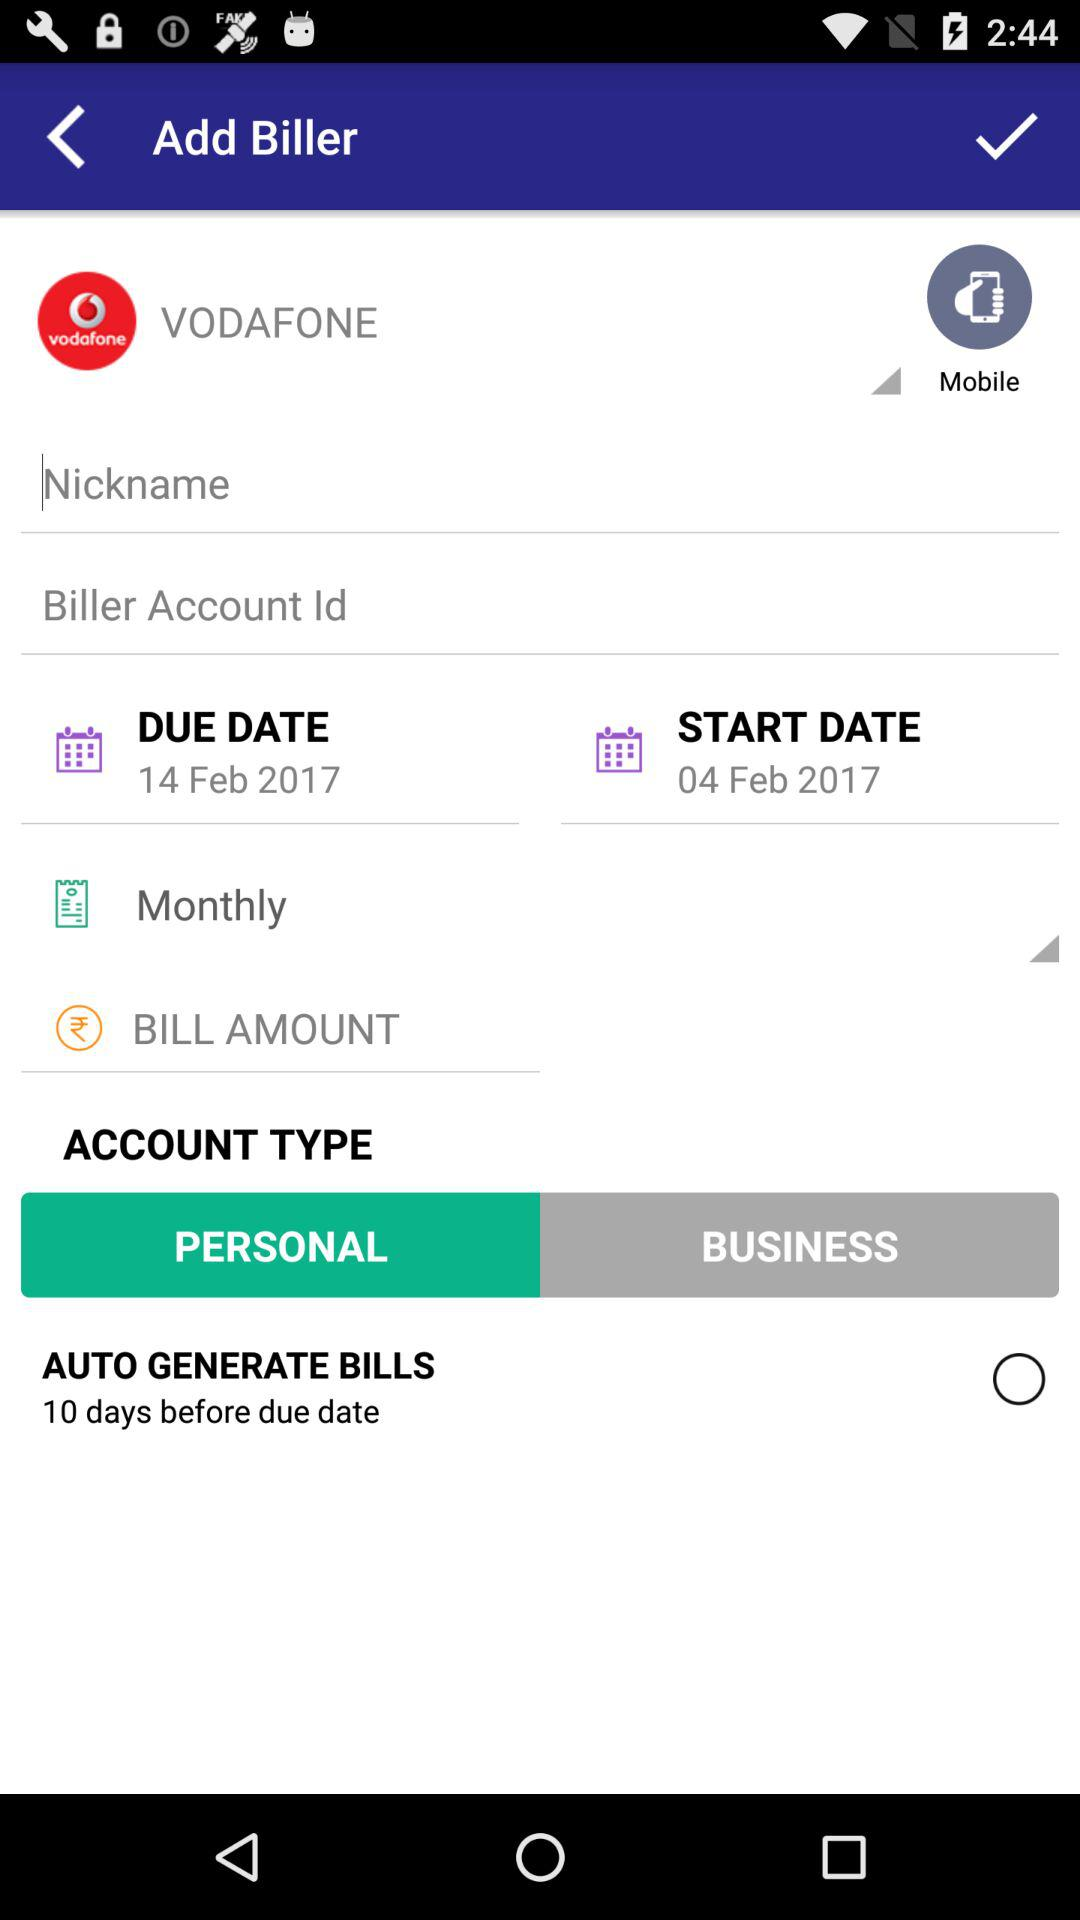What is the account type of the biller?
Answer the question using a single word or phrase. Personal 